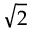Convert formula to latex. <formula><loc_0><loc_0><loc_500><loc_500>\sqrt { 2 }</formula> 